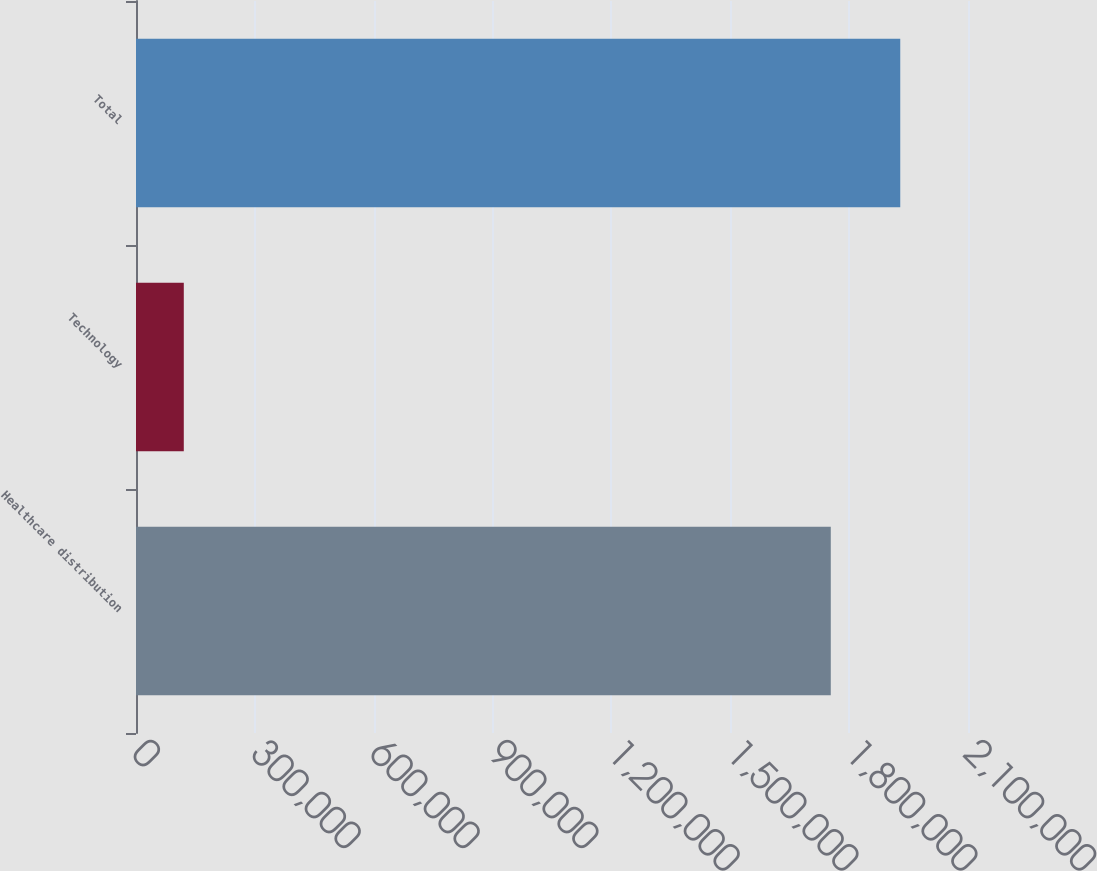Convert chart to OTSL. <chart><loc_0><loc_0><loc_500><loc_500><bar_chart><fcel>Healthcare distribution<fcel>Technology<fcel>Total<nl><fcel>1.75366e+06<fcel>120640<fcel>1.92902e+06<nl></chart> 